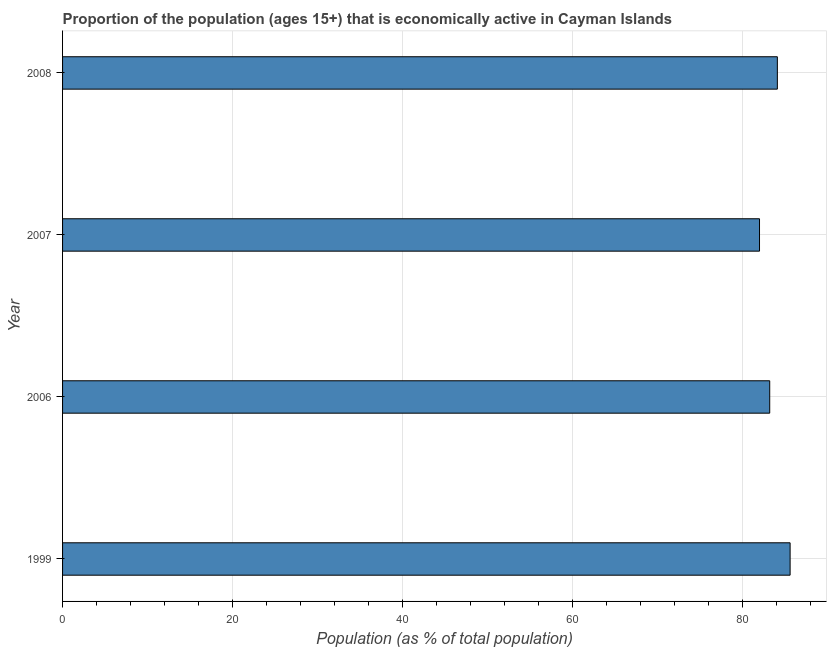What is the title of the graph?
Ensure brevity in your answer.  Proportion of the population (ages 15+) that is economically active in Cayman Islands. What is the label or title of the X-axis?
Provide a succinct answer. Population (as % of total population). What is the percentage of economically active population in 2007?
Offer a very short reply. 82. Across all years, what is the maximum percentage of economically active population?
Your response must be concise. 85.6. In which year was the percentage of economically active population maximum?
Offer a terse response. 1999. What is the sum of the percentage of economically active population?
Ensure brevity in your answer.  334.9. What is the difference between the percentage of economically active population in 2006 and 2007?
Your response must be concise. 1.2. What is the average percentage of economically active population per year?
Provide a short and direct response. 83.72. What is the median percentage of economically active population?
Provide a succinct answer. 83.65. Do a majority of the years between 1999 and 2008 (inclusive) have percentage of economically active population greater than 76 %?
Offer a very short reply. Yes. What is the ratio of the percentage of economically active population in 1999 to that in 2006?
Provide a succinct answer. 1.03. Is the percentage of economically active population in 2007 less than that in 2008?
Your answer should be very brief. Yes. What is the difference between the highest and the second highest percentage of economically active population?
Ensure brevity in your answer.  1.5. Is the sum of the percentage of economically active population in 2006 and 2008 greater than the maximum percentage of economically active population across all years?
Provide a succinct answer. Yes. How many bars are there?
Offer a terse response. 4. Are all the bars in the graph horizontal?
Give a very brief answer. Yes. What is the difference between two consecutive major ticks on the X-axis?
Provide a short and direct response. 20. What is the Population (as % of total population) of 1999?
Make the answer very short. 85.6. What is the Population (as % of total population) of 2006?
Make the answer very short. 83.2. What is the Population (as % of total population) of 2007?
Keep it short and to the point. 82. What is the Population (as % of total population) in 2008?
Offer a very short reply. 84.1. What is the difference between the Population (as % of total population) in 2006 and 2007?
Keep it short and to the point. 1.2. What is the difference between the Population (as % of total population) in 2006 and 2008?
Your answer should be compact. -0.9. What is the ratio of the Population (as % of total population) in 1999 to that in 2007?
Give a very brief answer. 1.04. What is the ratio of the Population (as % of total population) in 2007 to that in 2008?
Make the answer very short. 0.97. 